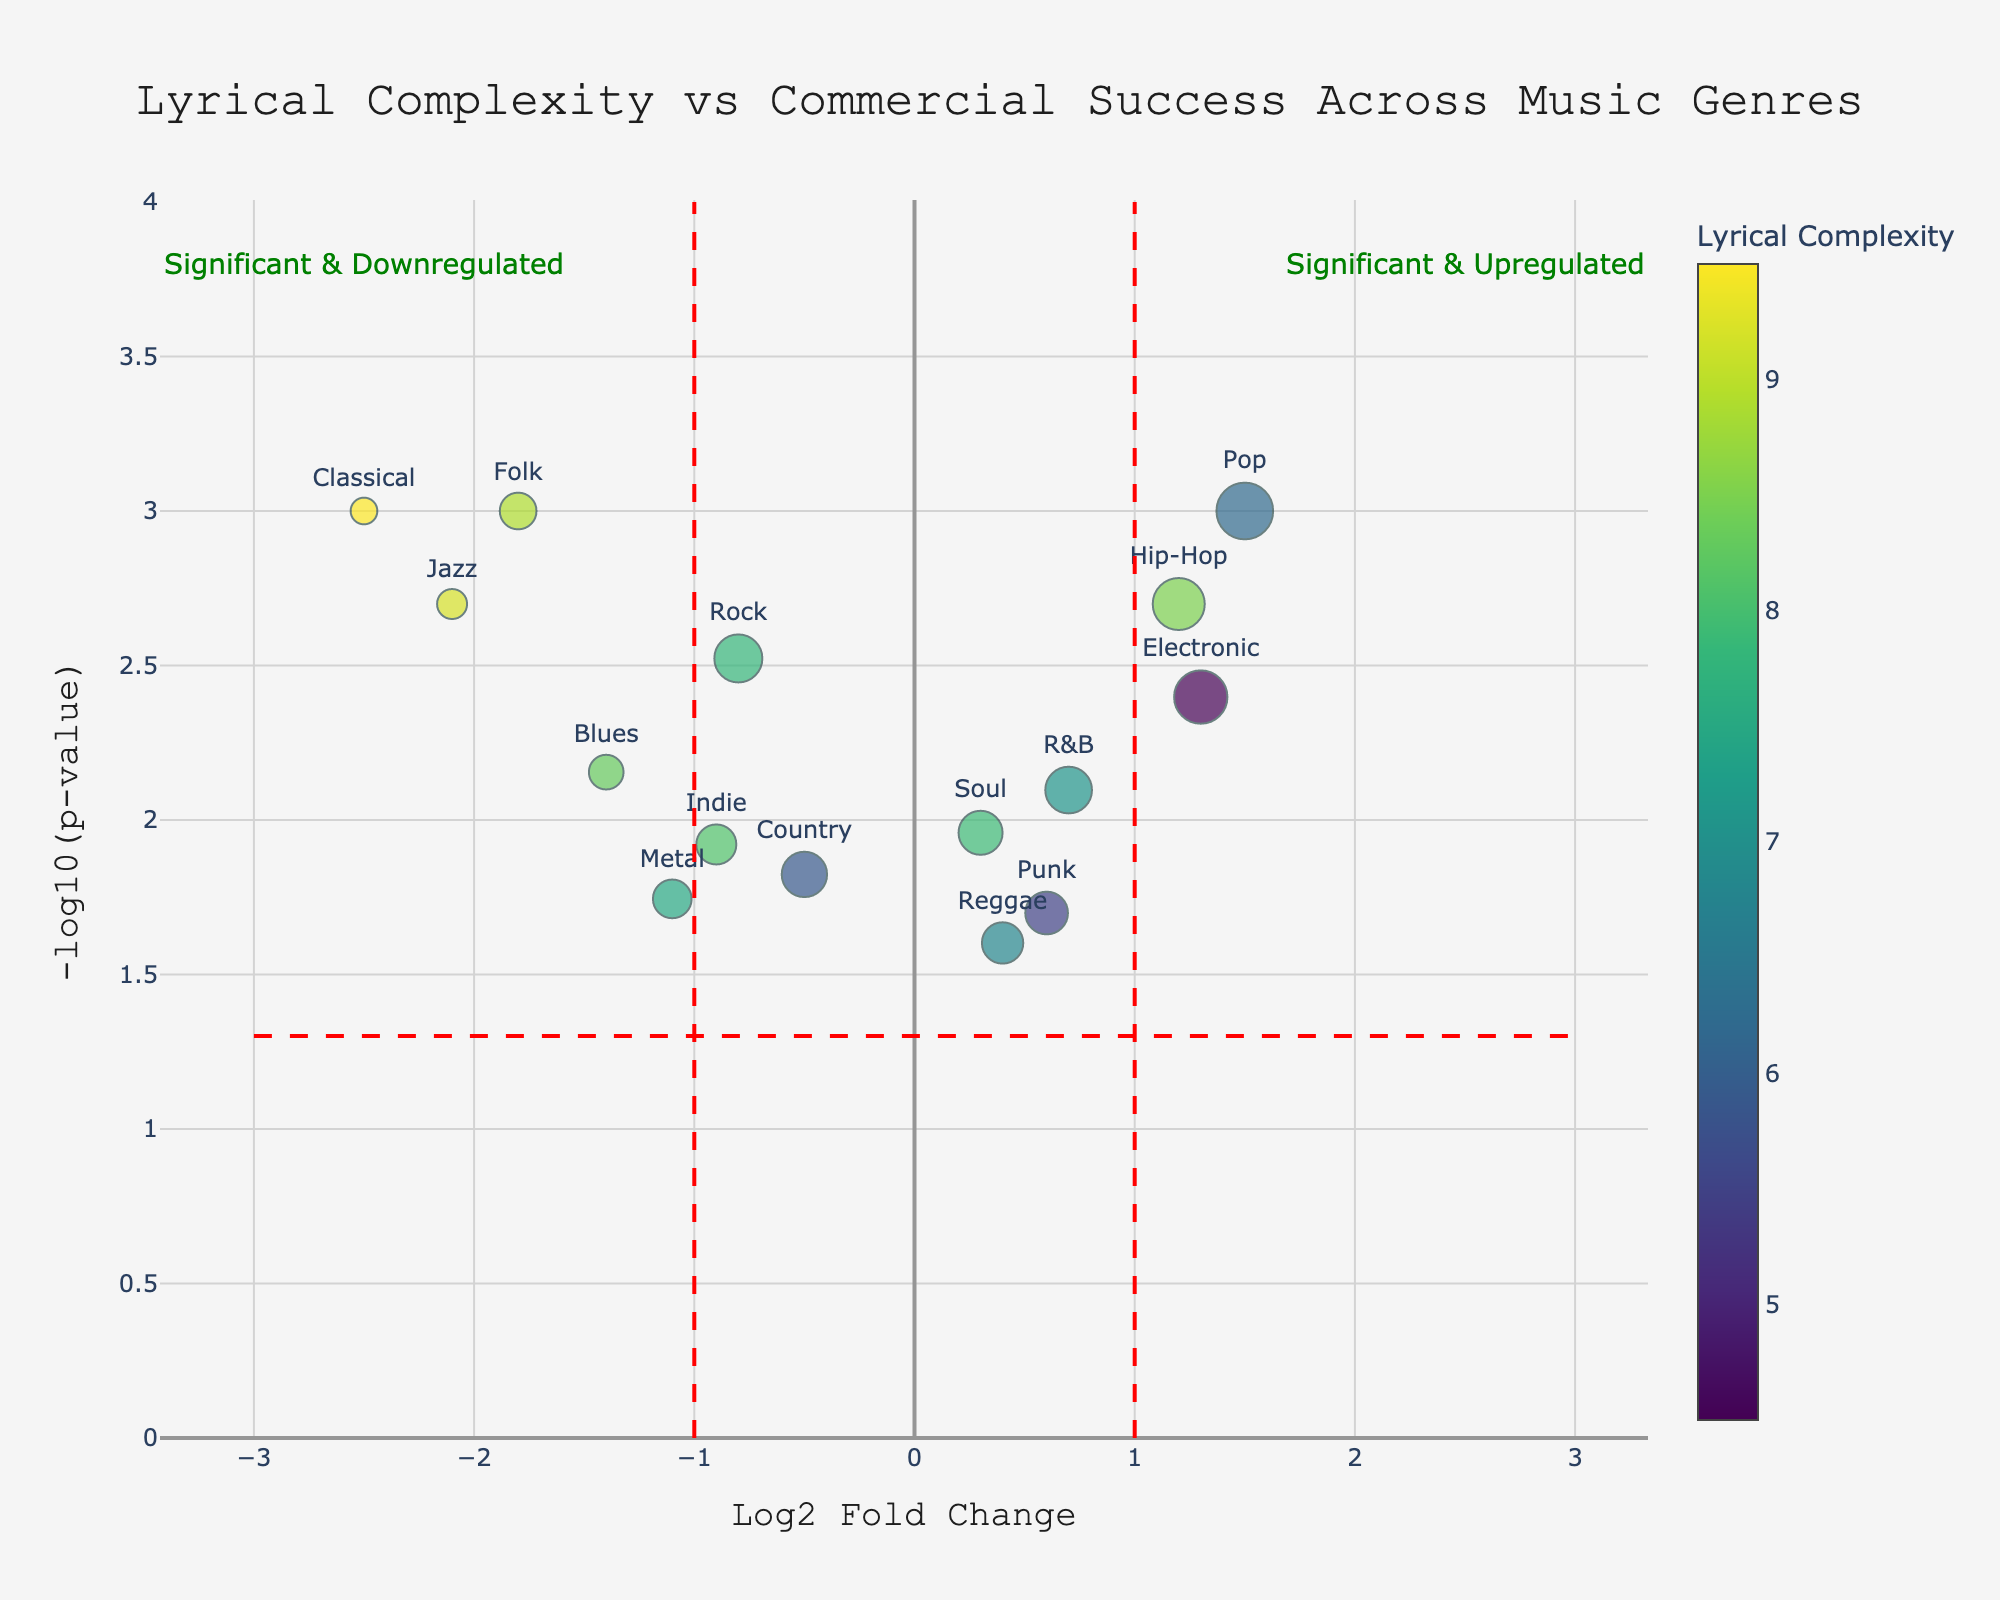What is the title of the Volcano Plot? The title is located at the top of the plot in a larger font size, serving as a brief description.
Answer: Lyrical Complexity vs Commercial Success Across Music Genres How many genres are shown in the plot? Count the number of distinct data points or genre names presented in the plot.
Answer: 15 Which genre has the highest lyrical complexity? The colorbar shows that higher lyrical complexity is indicated by more purple colors; locate the genre with the darkest purple color.
Answer: Classical Which genre has the highest -log10(p-value) score? Find the data point that is positioned the highest on the y-axis, which corresponds to the highest -log10(p-value) score.
Answer: Classical Identify a genre with a positive Log2 Fold Change that is statistically significant. Look for data points to the right of 1 on the x-axis and above the horizontal significance line.
Answer: Pop Which genre has the lowest commercial success? Check the sizes of the markers to identify the smallest marker, which corresponds to the lowest commercial success.
Answer: Classical Compare the lyrical complexities of Hip-Hop and Rock. Which one is higher? Refer to the color of the markers for Hip-Hop and Rock in the figure; the one with a more purple color has higher complexity.
Answer: Hip-Hop What does the vertical line at 1 on the x-axis indicate? The plot includes annotations and lines; the vertical line at 1 signifies the threshold for significant upregulation.
Answer: Significant upregulation threshold Among statistically significant genres, which has the largest fold change? Focus on genres above the horizontal significance line and look for the farthest point on the x-axis
Answer: Classical How are genres with higher commercial success visually represented? Observe the size of the markers; larger markers correspond to higher values on this metric.
Answer: Larger marker size 